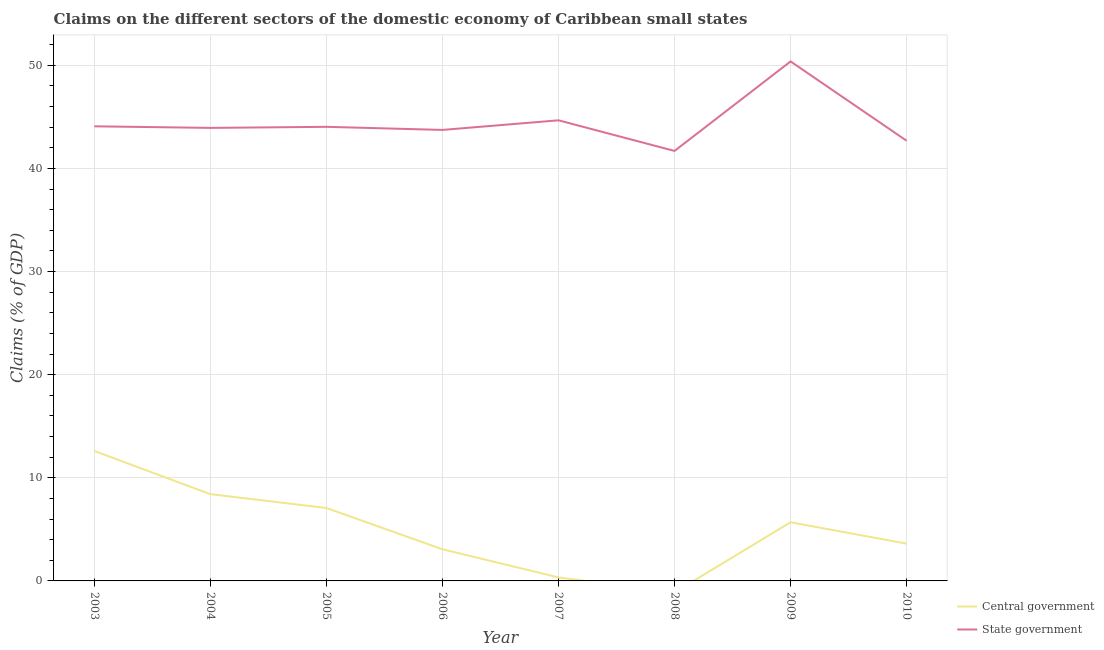How many different coloured lines are there?
Offer a terse response. 2. Does the line corresponding to claims on state government intersect with the line corresponding to claims on central government?
Provide a succinct answer. No. What is the claims on central government in 2008?
Your answer should be very brief. 0. Across all years, what is the maximum claims on state government?
Your answer should be very brief. 50.38. Across all years, what is the minimum claims on state government?
Offer a very short reply. 41.7. In which year was the claims on central government maximum?
Your response must be concise. 2003. What is the total claims on state government in the graph?
Offer a terse response. 355.2. What is the difference between the claims on state government in 2005 and that in 2007?
Give a very brief answer. -0.63. What is the difference between the claims on state government in 2005 and the claims on central government in 2007?
Provide a succinct answer. 43.69. What is the average claims on state government per year?
Provide a succinct answer. 44.4. In the year 2005, what is the difference between the claims on central government and claims on state government?
Offer a very short reply. -36.96. In how many years, is the claims on state government greater than 46 %?
Make the answer very short. 1. What is the ratio of the claims on central government in 2004 to that in 2007?
Provide a short and direct response. 24.59. Is the claims on state government in 2005 less than that in 2007?
Your answer should be compact. Yes. Is the difference between the claims on state government in 2007 and 2009 greater than the difference between the claims on central government in 2007 and 2009?
Offer a terse response. No. What is the difference between the highest and the second highest claims on state government?
Make the answer very short. 5.71. What is the difference between the highest and the lowest claims on state government?
Give a very brief answer. 8.68. Is the sum of the claims on central government in 2005 and 2010 greater than the maximum claims on state government across all years?
Ensure brevity in your answer.  No. Is the claims on state government strictly greater than the claims on central government over the years?
Offer a terse response. Yes. Does the graph contain any zero values?
Your answer should be very brief. Yes. How are the legend labels stacked?
Offer a very short reply. Vertical. What is the title of the graph?
Provide a succinct answer. Claims on the different sectors of the domestic economy of Caribbean small states. Does "Sanitation services" appear as one of the legend labels in the graph?
Make the answer very short. No. What is the label or title of the X-axis?
Give a very brief answer. Year. What is the label or title of the Y-axis?
Give a very brief answer. Claims (% of GDP). What is the Claims (% of GDP) in Central government in 2003?
Provide a short and direct response. 12.6. What is the Claims (% of GDP) in State government in 2003?
Offer a terse response. 44.08. What is the Claims (% of GDP) of Central government in 2004?
Provide a succinct answer. 8.41. What is the Claims (% of GDP) of State government in 2004?
Provide a short and direct response. 43.93. What is the Claims (% of GDP) of Central government in 2005?
Ensure brevity in your answer.  7.07. What is the Claims (% of GDP) in State government in 2005?
Give a very brief answer. 44.03. What is the Claims (% of GDP) of Central government in 2006?
Offer a terse response. 3.07. What is the Claims (% of GDP) in State government in 2006?
Provide a succinct answer. 43.73. What is the Claims (% of GDP) in Central government in 2007?
Keep it short and to the point. 0.34. What is the Claims (% of GDP) of State government in 2007?
Ensure brevity in your answer.  44.67. What is the Claims (% of GDP) of State government in 2008?
Make the answer very short. 41.7. What is the Claims (% of GDP) in Central government in 2009?
Your answer should be compact. 5.69. What is the Claims (% of GDP) in State government in 2009?
Give a very brief answer. 50.38. What is the Claims (% of GDP) of Central government in 2010?
Your answer should be compact. 3.61. What is the Claims (% of GDP) of State government in 2010?
Make the answer very short. 42.68. Across all years, what is the maximum Claims (% of GDP) in Central government?
Your response must be concise. 12.6. Across all years, what is the maximum Claims (% of GDP) of State government?
Your answer should be compact. 50.38. Across all years, what is the minimum Claims (% of GDP) of State government?
Keep it short and to the point. 41.7. What is the total Claims (% of GDP) of Central government in the graph?
Provide a short and direct response. 40.8. What is the total Claims (% of GDP) of State government in the graph?
Offer a terse response. 355.2. What is the difference between the Claims (% of GDP) of Central government in 2003 and that in 2004?
Provide a short and direct response. 4.19. What is the difference between the Claims (% of GDP) in State government in 2003 and that in 2004?
Provide a succinct answer. 0.15. What is the difference between the Claims (% of GDP) of Central government in 2003 and that in 2005?
Your answer should be compact. 5.53. What is the difference between the Claims (% of GDP) in Central government in 2003 and that in 2006?
Provide a short and direct response. 9.53. What is the difference between the Claims (% of GDP) in State government in 2003 and that in 2006?
Offer a very short reply. 0.35. What is the difference between the Claims (% of GDP) in Central government in 2003 and that in 2007?
Your answer should be compact. 12.26. What is the difference between the Claims (% of GDP) of State government in 2003 and that in 2007?
Your answer should be very brief. -0.58. What is the difference between the Claims (% of GDP) of State government in 2003 and that in 2008?
Keep it short and to the point. 2.39. What is the difference between the Claims (% of GDP) of Central government in 2003 and that in 2009?
Give a very brief answer. 6.91. What is the difference between the Claims (% of GDP) of State government in 2003 and that in 2009?
Your response must be concise. -6.29. What is the difference between the Claims (% of GDP) in Central government in 2003 and that in 2010?
Make the answer very short. 8.99. What is the difference between the Claims (% of GDP) of State government in 2003 and that in 2010?
Your answer should be very brief. 1.4. What is the difference between the Claims (% of GDP) of Central government in 2004 and that in 2005?
Keep it short and to the point. 1.34. What is the difference between the Claims (% of GDP) of State government in 2004 and that in 2005?
Offer a very short reply. -0.1. What is the difference between the Claims (% of GDP) of Central government in 2004 and that in 2006?
Provide a succinct answer. 5.35. What is the difference between the Claims (% of GDP) of State government in 2004 and that in 2006?
Provide a succinct answer. 0.2. What is the difference between the Claims (% of GDP) of Central government in 2004 and that in 2007?
Your answer should be very brief. 8.07. What is the difference between the Claims (% of GDP) in State government in 2004 and that in 2007?
Provide a short and direct response. -0.74. What is the difference between the Claims (% of GDP) in State government in 2004 and that in 2008?
Your answer should be very brief. 2.23. What is the difference between the Claims (% of GDP) of Central government in 2004 and that in 2009?
Your answer should be compact. 2.73. What is the difference between the Claims (% of GDP) in State government in 2004 and that in 2009?
Ensure brevity in your answer.  -6.45. What is the difference between the Claims (% of GDP) in Central government in 2004 and that in 2010?
Offer a very short reply. 4.8. What is the difference between the Claims (% of GDP) in State government in 2004 and that in 2010?
Your answer should be compact. 1.25. What is the difference between the Claims (% of GDP) in Central government in 2005 and that in 2006?
Offer a terse response. 4.01. What is the difference between the Claims (% of GDP) of State government in 2005 and that in 2006?
Make the answer very short. 0.3. What is the difference between the Claims (% of GDP) in Central government in 2005 and that in 2007?
Your response must be concise. 6.73. What is the difference between the Claims (% of GDP) in State government in 2005 and that in 2007?
Offer a terse response. -0.63. What is the difference between the Claims (% of GDP) in State government in 2005 and that in 2008?
Keep it short and to the point. 2.34. What is the difference between the Claims (% of GDP) of Central government in 2005 and that in 2009?
Provide a short and direct response. 1.39. What is the difference between the Claims (% of GDP) of State government in 2005 and that in 2009?
Your response must be concise. -6.34. What is the difference between the Claims (% of GDP) in Central government in 2005 and that in 2010?
Keep it short and to the point. 3.46. What is the difference between the Claims (% of GDP) of State government in 2005 and that in 2010?
Provide a succinct answer. 1.35. What is the difference between the Claims (% of GDP) of Central government in 2006 and that in 2007?
Provide a succinct answer. 2.73. What is the difference between the Claims (% of GDP) in State government in 2006 and that in 2007?
Your answer should be compact. -0.93. What is the difference between the Claims (% of GDP) in State government in 2006 and that in 2008?
Provide a short and direct response. 2.04. What is the difference between the Claims (% of GDP) of Central government in 2006 and that in 2009?
Your answer should be very brief. -2.62. What is the difference between the Claims (% of GDP) in State government in 2006 and that in 2009?
Provide a succinct answer. -6.64. What is the difference between the Claims (% of GDP) of Central government in 2006 and that in 2010?
Ensure brevity in your answer.  -0.55. What is the difference between the Claims (% of GDP) in State government in 2006 and that in 2010?
Give a very brief answer. 1.05. What is the difference between the Claims (% of GDP) of State government in 2007 and that in 2008?
Your response must be concise. 2.97. What is the difference between the Claims (% of GDP) of Central government in 2007 and that in 2009?
Keep it short and to the point. -5.35. What is the difference between the Claims (% of GDP) in State government in 2007 and that in 2009?
Give a very brief answer. -5.71. What is the difference between the Claims (% of GDP) of Central government in 2007 and that in 2010?
Offer a terse response. -3.27. What is the difference between the Claims (% of GDP) in State government in 2007 and that in 2010?
Make the answer very short. 1.98. What is the difference between the Claims (% of GDP) of State government in 2008 and that in 2009?
Ensure brevity in your answer.  -8.68. What is the difference between the Claims (% of GDP) in State government in 2008 and that in 2010?
Your answer should be very brief. -0.99. What is the difference between the Claims (% of GDP) of Central government in 2009 and that in 2010?
Make the answer very short. 2.07. What is the difference between the Claims (% of GDP) of State government in 2009 and that in 2010?
Make the answer very short. 7.69. What is the difference between the Claims (% of GDP) of Central government in 2003 and the Claims (% of GDP) of State government in 2004?
Offer a very short reply. -31.33. What is the difference between the Claims (% of GDP) in Central government in 2003 and the Claims (% of GDP) in State government in 2005?
Give a very brief answer. -31.43. What is the difference between the Claims (% of GDP) in Central government in 2003 and the Claims (% of GDP) in State government in 2006?
Offer a very short reply. -31.13. What is the difference between the Claims (% of GDP) of Central government in 2003 and the Claims (% of GDP) of State government in 2007?
Ensure brevity in your answer.  -32.06. What is the difference between the Claims (% of GDP) in Central government in 2003 and the Claims (% of GDP) in State government in 2008?
Provide a succinct answer. -29.09. What is the difference between the Claims (% of GDP) of Central government in 2003 and the Claims (% of GDP) of State government in 2009?
Keep it short and to the point. -37.77. What is the difference between the Claims (% of GDP) of Central government in 2003 and the Claims (% of GDP) of State government in 2010?
Make the answer very short. -30.08. What is the difference between the Claims (% of GDP) of Central government in 2004 and the Claims (% of GDP) of State government in 2005?
Your answer should be very brief. -35.62. What is the difference between the Claims (% of GDP) of Central government in 2004 and the Claims (% of GDP) of State government in 2006?
Your answer should be compact. -35.32. What is the difference between the Claims (% of GDP) in Central government in 2004 and the Claims (% of GDP) in State government in 2007?
Make the answer very short. -36.25. What is the difference between the Claims (% of GDP) of Central government in 2004 and the Claims (% of GDP) of State government in 2008?
Make the answer very short. -33.28. What is the difference between the Claims (% of GDP) of Central government in 2004 and the Claims (% of GDP) of State government in 2009?
Provide a short and direct response. -41.96. What is the difference between the Claims (% of GDP) in Central government in 2004 and the Claims (% of GDP) in State government in 2010?
Make the answer very short. -34.27. What is the difference between the Claims (% of GDP) in Central government in 2005 and the Claims (% of GDP) in State government in 2006?
Offer a terse response. -36.66. What is the difference between the Claims (% of GDP) in Central government in 2005 and the Claims (% of GDP) in State government in 2007?
Make the answer very short. -37.59. What is the difference between the Claims (% of GDP) of Central government in 2005 and the Claims (% of GDP) of State government in 2008?
Ensure brevity in your answer.  -34.62. What is the difference between the Claims (% of GDP) of Central government in 2005 and the Claims (% of GDP) of State government in 2009?
Give a very brief answer. -43.3. What is the difference between the Claims (% of GDP) of Central government in 2005 and the Claims (% of GDP) of State government in 2010?
Provide a succinct answer. -35.61. What is the difference between the Claims (% of GDP) in Central government in 2006 and the Claims (% of GDP) in State government in 2007?
Your answer should be compact. -41.6. What is the difference between the Claims (% of GDP) in Central government in 2006 and the Claims (% of GDP) in State government in 2008?
Your answer should be compact. -38.63. What is the difference between the Claims (% of GDP) of Central government in 2006 and the Claims (% of GDP) of State government in 2009?
Provide a short and direct response. -47.31. What is the difference between the Claims (% of GDP) in Central government in 2006 and the Claims (% of GDP) in State government in 2010?
Ensure brevity in your answer.  -39.61. What is the difference between the Claims (% of GDP) in Central government in 2007 and the Claims (% of GDP) in State government in 2008?
Provide a succinct answer. -41.35. What is the difference between the Claims (% of GDP) of Central government in 2007 and the Claims (% of GDP) of State government in 2009?
Make the answer very short. -50.03. What is the difference between the Claims (% of GDP) of Central government in 2007 and the Claims (% of GDP) of State government in 2010?
Your answer should be compact. -42.34. What is the difference between the Claims (% of GDP) in Central government in 2009 and the Claims (% of GDP) in State government in 2010?
Make the answer very short. -36.99. What is the average Claims (% of GDP) in Central government per year?
Your answer should be very brief. 5.1. What is the average Claims (% of GDP) in State government per year?
Keep it short and to the point. 44.4. In the year 2003, what is the difference between the Claims (% of GDP) of Central government and Claims (% of GDP) of State government?
Your response must be concise. -31.48. In the year 2004, what is the difference between the Claims (% of GDP) of Central government and Claims (% of GDP) of State government?
Provide a succinct answer. -35.52. In the year 2005, what is the difference between the Claims (% of GDP) of Central government and Claims (% of GDP) of State government?
Your answer should be very brief. -36.96. In the year 2006, what is the difference between the Claims (% of GDP) in Central government and Claims (% of GDP) in State government?
Give a very brief answer. -40.67. In the year 2007, what is the difference between the Claims (% of GDP) in Central government and Claims (% of GDP) in State government?
Keep it short and to the point. -44.32. In the year 2009, what is the difference between the Claims (% of GDP) in Central government and Claims (% of GDP) in State government?
Provide a short and direct response. -44.69. In the year 2010, what is the difference between the Claims (% of GDP) in Central government and Claims (% of GDP) in State government?
Offer a very short reply. -39.07. What is the ratio of the Claims (% of GDP) in Central government in 2003 to that in 2004?
Your answer should be compact. 1.5. What is the ratio of the Claims (% of GDP) of Central government in 2003 to that in 2005?
Your answer should be compact. 1.78. What is the ratio of the Claims (% of GDP) in Central government in 2003 to that in 2006?
Give a very brief answer. 4.11. What is the ratio of the Claims (% of GDP) in State government in 2003 to that in 2006?
Ensure brevity in your answer.  1.01. What is the ratio of the Claims (% of GDP) in Central government in 2003 to that in 2007?
Provide a short and direct response. 36.83. What is the ratio of the Claims (% of GDP) in State government in 2003 to that in 2007?
Your answer should be very brief. 0.99. What is the ratio of the Claims (% of GDP) of State government in 2003 to that in 2008?
Your answer should be very brief. 1.06. What is the ratio of the Claims (% of GDP) in Central government in 2003 to that in 2009?
Provide a succinct answer. 2.22. What is the ratio of the Claims (% of GDP) in State government in 2003 to that in 2009?
Provide a short and direct response. 0.88. What is the ratio of the Claims (% of GDP) in Central government in 2003 to that in 2010?
Your answer should be compact. 3.49. What is the ratio of the Claims (% of GDP) of State government in 2003 to that in 2010?
Give a very brief answer. 1.03. What is the ratio of the Claims (% of GDP) of Central government in 2004 to that in 2005?
Make the answer very short. 1.19. What is the ratio of the Claims (% of GDP) of Central government in 2004 to that in 2006?
Your response must be concise. 2.74. What is the ratio of the Claims (% of GDP) of State government in 2004 to that in 2006?
Ensure brevity in your answer.  1. What is the ratio of the Claims (% of GDP) in Central government in 2004 to that in 2007?
Your response must be concise. 24.59. What is the ratio of the Claims (% of GDP) of State government in 2004 to that in 2007?
Provide a succinct answer. 0.98. What is the ratio of the Claims (% of GDP) in State government in 2004 to that in 2008?
Your response must be concise. 1.05. What is the ratio of the Claims (% of GDP) in Central government in 2004 to that in 2009?
Keep it short and to the point. 1.48. What is the ratio of the Claims (% of GDP) of State government in 2004 to that in 2009?
Your answer should be compact. 0.87. What is the ratio of the Claims (% of GDP) in Central government in 2004 to that in 2010?
Provide a short and direct response. 2.33. What is the ratio of the Claims (% of GDP) of State government in 2004 to that in 2010?
Provide a short and direct response. 1.03. What is the ratio of the Claims (% of GDP) in Central government in 2005 to that in 2006?
Your response must be concise. 2.31. What is the ratio of the Claims (% of GDP) of State government in 2005 to that in 2006?
Give a very brief answer. 1.01. What is the ratio of the Claims (% of GDP) in Central government in 2005 to that in 2007?
Your response must be concise. 20.67. What is the ratio of the Claims (% of GDP) in State government in 2005 to that in 2007?
Your answer should be very brief. 0.99. What is the ratio of the Claims (% of GDP) in State government in 2005 to that in 2008?
Give a very brief answer. 1.06. What is the ratio of the Claims (% of GDP) of Central government in 2005 to that in 2009?
Offer a terse response. 1.24. What is the ratio of the Claims (% of GDP) of State government in 2005 to that in 2009?
Ensure brevity in your answer.  0.87. What is the ratio of the Claims (% of GDP) in Central government in 2005 to that in 2010?
Your response must be concise. 1.96. What is the ratio of the Claims (% of GDP) of State government in 2005 to that in 2010?
Your answer should be compact. 1.03. What is the ratio of the Claims (% of GDP) of Central government in 2006 to that in 2007?
Offer a very short reply. 8.96. What is the ratio of the Claims (% of GDP) in State government in 2006 to that in 2007?
Your answer should be compact. 0.98. What is the ratio of the Claims (% of GDP) in State government in 2006 to that in 2008?
Give a very brief answer. 1.05. What is the ratio of the Claims (% of GDP) of Central government in 2006 to that in 2009?
Provide a short and direct response. 0.54. What is the ratio of the Claims (% of GDP) of State government in 2006 to that in 2009?
Provide a succinct answer. 0.87. What is the ratio of the Claims (% of GDP) in Central government in 2006 to that in 2010?
Provide a short and direct response. 0.85. What is the ratio of the Claims (% of GDP) in State government in 2006 to that in 2010?
Provide a succinct answer. 1.02. What is the ratio of the Claims (% of GDP) in State government in 2007 to that in 2008?
Your answer should be very brief. 1.07. What is the ratio of the Claims (% of GDP) in Central government in 2007 to that in 2009?
Keep it short and to the point. 0.06. What is the ratio of the Claims (% of GDP) of State government in 2007 to that in 2009?
Make the answer very short. 0.89. What is the ratio of the Claims (% of GDP) in Central government in 2007 to that in 2010?
Provide a succinct answer. 0.09. What is the ratio of the Claims (% of GDP) of State government in 2007 to that in 2010?
Your response must be concise. 1.05. What is the ratio of the Claims (% of GDP) of State government in 2008 to that in 2009?
Give a very brief answer. 0.83. What is the ratio of the Claims (% of GDP) of State government in 2008 to that in 2010?
Offer a very short reply. 0.98. What is the ratio of the Claims (% of GDP) in Central government in 2009 to that in 2010?
Offer a very short reply. 1.57. What is the ratio of the Claims (% of GDP) in State government in 2009 to that in 2010?
Offer a very short reply. 1.18. What is the difference between the highest and the second highest Claims (% of GDP) in Central government?
Give a very brief answer. 4.19. What is the difference between the highest and the second highest Claims (% of GDP) in State government?
Offer a very short reply. 5.71. What is the difference between the highest and the lowest Claims (% of GDP) in Central government?
Make the answer very short. 12.6. What is the difference between the highest and the lowest Claims (% of GDP) in State government?
Your answer should be very brief. 8.68. 